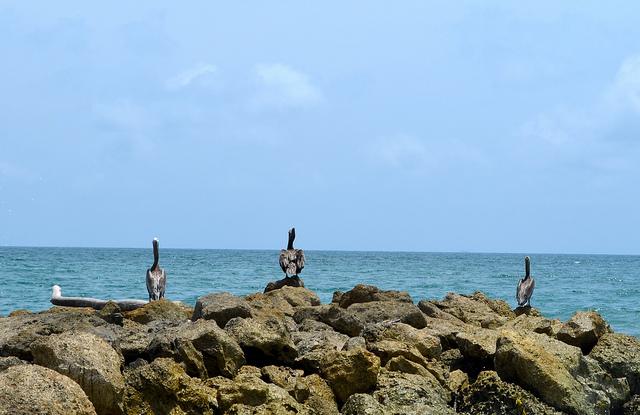What type of birds are those?
Answer briefly. Seagulls. Is the sky more blue than the water?
Keep it brief. No. Is there an island in the distance?
Write a very short answer. No. What are the birds standing on?
Quick response, please. Rocks. Is there a lot of penguins in this picture?
Answer briefly. No. What is the bird doing?
Short answer required. Sitting. 